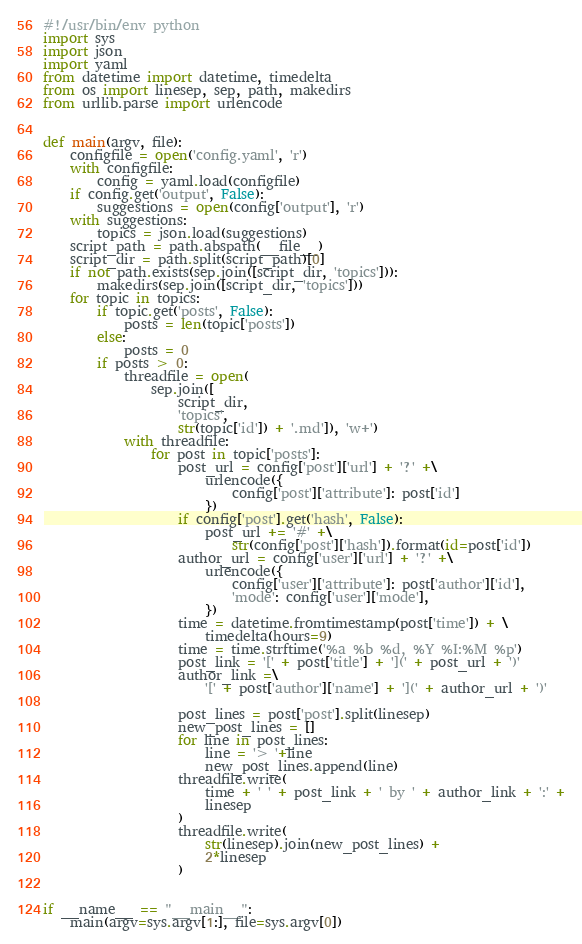<code> <loc_0><loc_0><loc_500><loc_500><_Python_>#!/usr/bin/env python
import sys
import json
import yaml
from datetime import datetime, timedelta
from os import linesep, sep, path, makedirs
from urllib.parse import urlencode


def main(argv, file):
    configfile = open('config.yaml', 'r')
    with configfile:
        config = yaml.load(configfile)
    if config.get('output', False):
        suggestions = open(config['output'], 'r')
    with suggestions:
        topics = json.load(suggestions)
    script_path = path.abspath(__file__)
    script_dir = path.split(script_path)[0]
    if not path.exists(sep.join([script_dir, 'topics'])):
        makedirs(sep.join([script_dir, 'topics']))
    for topic in topics:
        if topic.get('posts', False):
            posts = len(topic['posts'])
        else:
            posts = 0
        if posts > 0:
            threadfile = open(
                sep.join([
                    script_dir,
                    'topics',
                    str(topic['id']) + '.md']), 'w+')
            with threadfile:
                for post in topic['posts']:
                    post_url = config['post']['url'] + '?' +\
                        urlencode({
                            config['post']['attribute']: post['id']
                        })
                    if config['post'].get('hash', False):
                        post_url += '#' +\
                            str(config['post']['hash']).format(id=post['id'])
                    author_url = config['user']['url'] + '?' +\
                        urlencode({
                            config['user']['attribute']: post['author']['id'],
                            'mode': config['user']['mode'],
                        })
                    time = datetime.fromtimestamp(post['time']) + \
                        timedelta(hours=9)
                    time = time.strftime('%a %b %d, %Y %I:%M %p')
                    post_link = '[' + post['title'] + '](' + post_url + ')'
                    author_link =\
                        '[' + post['author']['name'] + '](' + author_url + ')'

                    post_lines = post['post'].split(linesep)
                    new_post_lines = []
                    for line in post_lines:
                        line = '> '+line
                        new_post_lines.append(line)
                    threadfile.write(
                        time + ' ' + post_link + ' by ' + author_link + ':' +
                        linesep
                    )
                    threadfile.write(
                        str(linesep).join(new_post_lines) +
                        2*linesep
                    )


if __name__ == "__main__":
    main(argv=sys.argv[1:], file=sys.argv[0])
</code> 